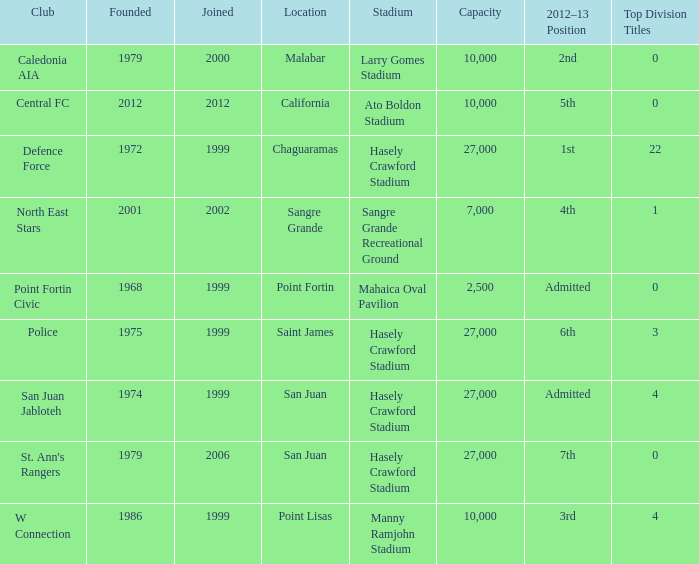In chaguaramas, what is the total count of top division titles held by teams established before 1975? 22.0. 